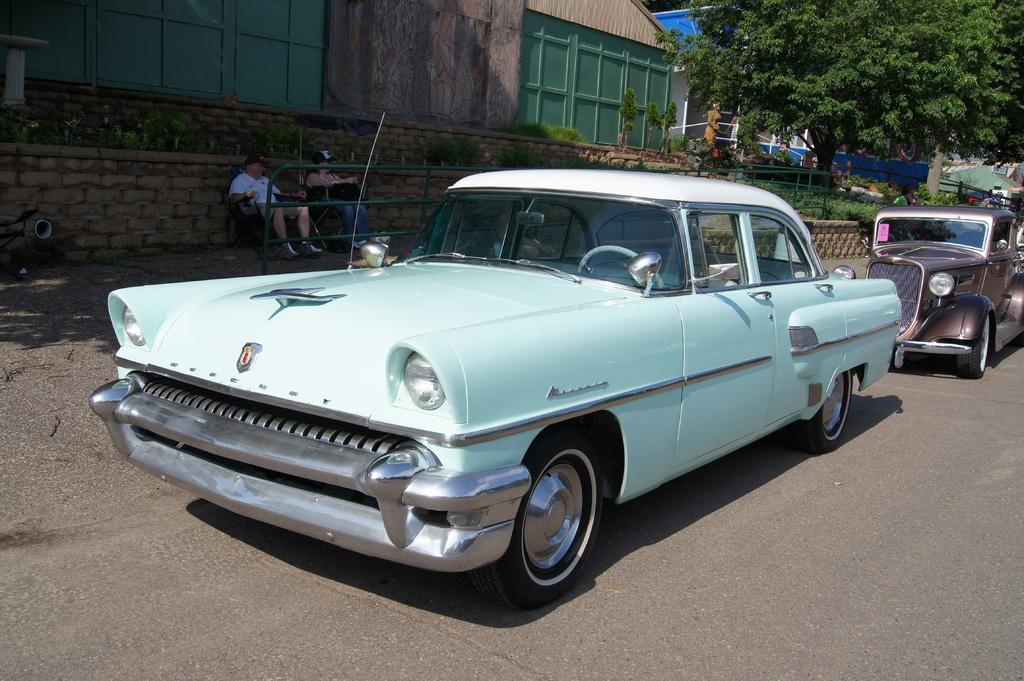What can be seen on the road in the image? There are cars on the road in the image. What type of structures are visible in the image? There are buildings in the image. What type of vegetation is present in the image? There are trees and plants in the image. What type of artwork is present in the image? There is a statue in the image. What type of barrier is present in the image? There is a fence in the image. What are the two people in the image doing? The two people are sitting on chairs in the image. What type of tin can be seen in the image? There is no tin present in the image. Can you describe the flight of the pigs in the image? There are no pigs present in the image, so there is no flight to describe. 